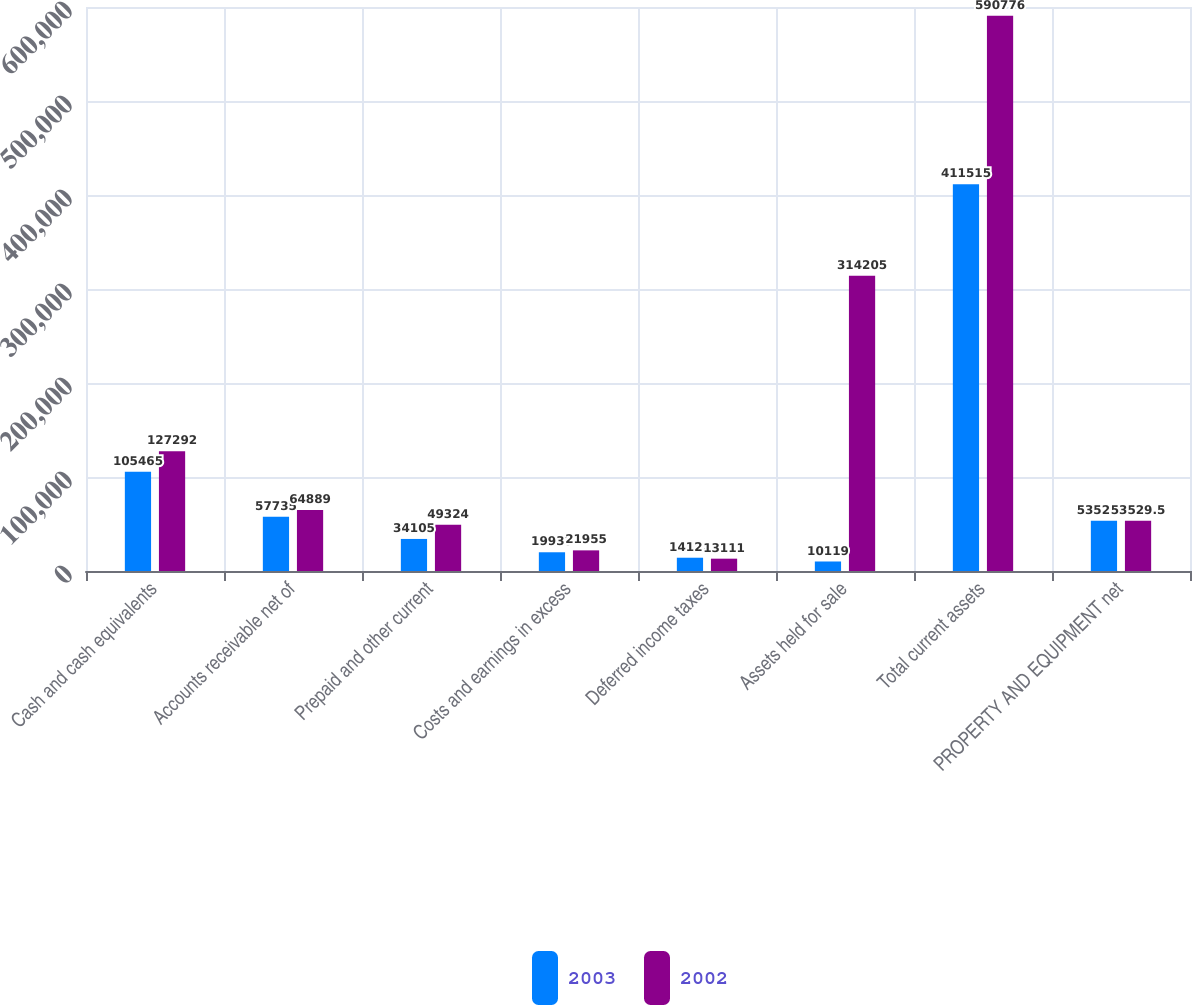<chart> <loc_0><loc_0><loc_500><loc_500><stacked_bar_chart><ecel><fcel>Cash and cash equivalents<fcel>Accounts receivable net of<fcel>Prepaid and other current<fcel>Costs and earnings in excess<fcel>Deferred income taxes<fcel>Assets held for sale<fcel>Total current assets<fcel>PROPERTY AND EQUIPMENT net<nl><fcel>2003<fcel>105465<fcel>57735<fcel>34105<fcel>19933<fcel>14122<fcel>10119<fcel>411515<fcel>53529.5<nl><fcel>2002<fcel>127292<fcel>64889<fcel>49324<fcel>21955<fcel>13111<fcel>314205<fcel>590776<fcel>53529.5<nl></chart> 